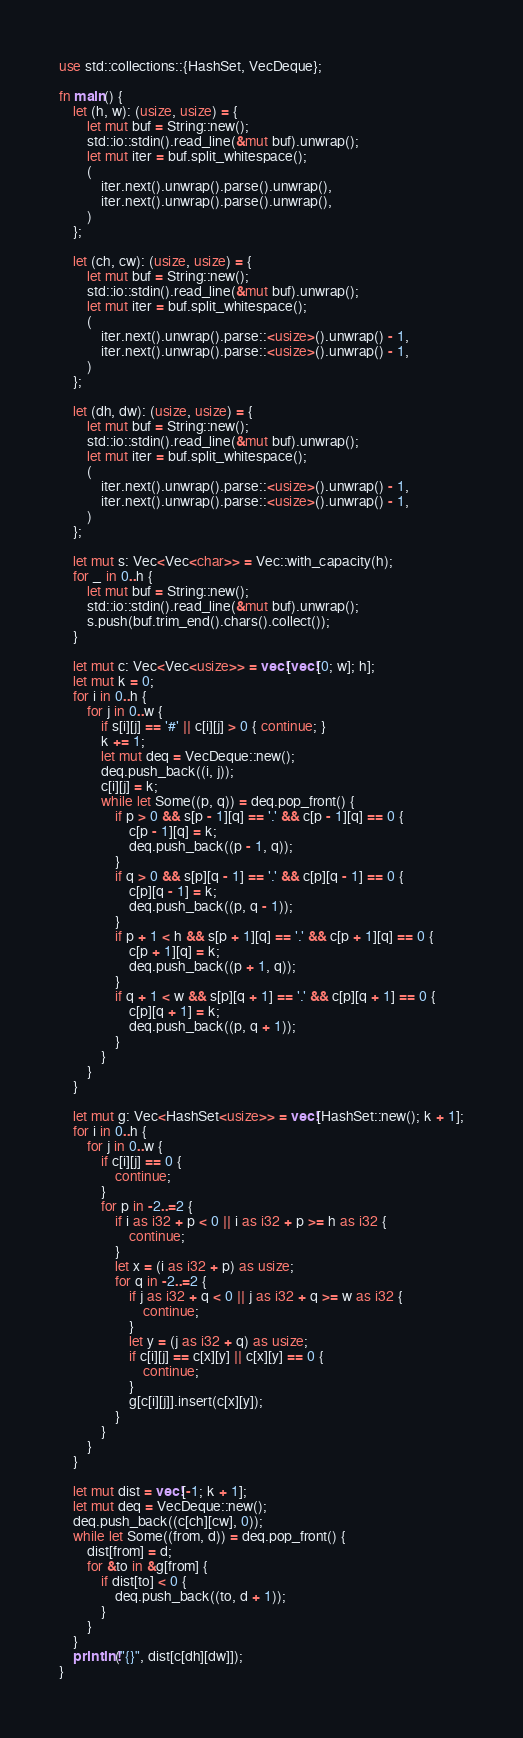<code> <loc_0><loc_0><loc_500><loc_500><_Rust_>use std::collections::{HashSet, VecDeque};

fn main() {
    let (h, w): (usize, usize) = {
        let mut buf = String::new();
        std::io::stdin().read_line(&mut buf).unwrap();
        let mut iter = buf.split_whitespace();
        (
            iter.next().unwrap().parse().unwrap(),
            iter.next().unwrap().parse().unwrap(),
        )
    };

    let (ch, cw): (usize, usize) = {
        let mut buf = String::new();
        std::io::stdin().read_line(&mut buf).unwrap();
        let mut iter = buf.split_whitespace();
        (
            iter.next().unwrap().parse::<usize>().unwrap() - 1,
            iter.next().unwrap().parse::<usize>().unwrap() - 1,
        )
    };

    let (dh, dw): (usize, usize) = {
        let mut buf = String::new();
        std::io::stdin().read_line(&mut buf).unwrap();
        let mut iter = buf.split_whitespace();
        (
            iter.next().unwrap().parse::<usize>().unwrap() - 1,
            iter.next().unwrap().parse::<usize>().unwrap() - 1,
        )
    };

    let mut s: Vec<Vec<char>> = Vec::with_capacity(h);
    for _ in 0..h {
        let mut buf = String::new();
        std::io::stdin().read_line(&mut buf).unwrap();
        s.push(buf.trim_end().chars().collect());
    }

    let mut c: Vec<Vec<usize>> = vec![vec![0; w]; h];
    let mut k = 0;
    for i in 0..h {
        for j in 0..w {
            if s[i][j] == '#' || c[i][j] > 0 { continue; }
            k += 1;
            let mut deq = VecDeque::new();
            deq.push_back((i, j));
            c[i][j] = k;
            while let Some((p, q)) = deq.pop_front() {
                if p > 0 && s[p - 1][q] == '.' && c[p - 1][q] == 0 {
                    c[p - 1][q] = k;
                    deq.push_back((p - 1, q));
                }
                if q > 0 && s[p][q - 1] == '.' && c[p][q - 1] == 0 {
                    c[p][q - 1] = k;
                    deq.push_back((p, q - 1));
                }
                if p + 1 < h && s[p + 1][q] == '.' && c[p + 1][q] == 0 {
                    c[p + 1][q] = k;
                    deq.push_back((p + 1, q));
                }
                if q + 1 < w && s[p][q + 1] == '.' && c[p][q + 1] == 0 {
                    c[p][q + 1] = k;
                    deq.push_back((p, q + 1));
                }
            }
        }
    }

    let mut g: Vec<HashSet<usize>> = vec![HashSet::new(); k + 1];
    for i in 0..h {
        for j in 0..w {
            if c[i][j] == 0 {
                continue;
            }
            for p in -2..=2 {
                if i as i32 + p < 0 || i as i32 + p >= h as i32 {
                    continue;
                }
                let x = (i as i32 + p) as usize;
                for q in -2..=2 {
                    if j as i32 + q < 0 || j as i32 + q >= w as i32 {
                        continue;
                    }
                    let y = (j as i32 + q) as usize;
                    if c[i][j] == c[x][y] || c[x][y] == 0 {
                        continue;
                    }
                    g[c[i][j]].insert(c[x][y]);
                }
            }
        }
    }

    let mut dist = vec![-1; k + 1];
    let mut deq = VecDeque::new();
    deq.push_back((c[ch][cw], 0));
    while let Some((from, d)) = deq.pop_front() {
        dist[from] = d;
        for &to in &g[from] {
            if dist[to] < 0 {
                deq.push_back((to, d + 1));
            }
        }
    }
    println!("{}", dist[c[dh][dw]]);
}</code> 